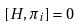<formula> <loc_0><loc_0><loc_500><loc_500>[ H , \pi _ { i } ] = 0</formula> 